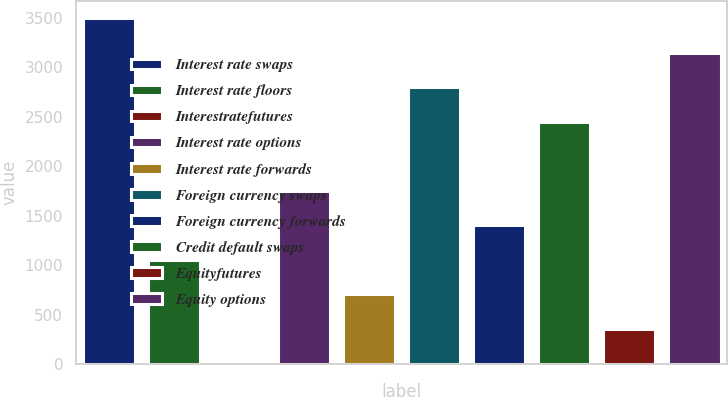Convert chart. <chart><loc_0><loc_0><loc_500><loc_500><bar_chart><fcel>Interest rate swaps<fcel>Interest rate floors<fcel>Interestratefutures<fcel>Interest rate options<fcel>Interest rate forwards<fcel>Foreign currency swaps<fcel>Foreign currency forwards<fcel>Credit default swaps<fcel>Equityfutures<fcel>Equity options<nl><fcel>3494<fcel>1055.2<fcel>10<fcel>1752<fcel>706.8<fcel>2797.2<fcel>1403.6<fcel>2448.8<fcel>358.4<fcel>3145.6<nl></chart> 